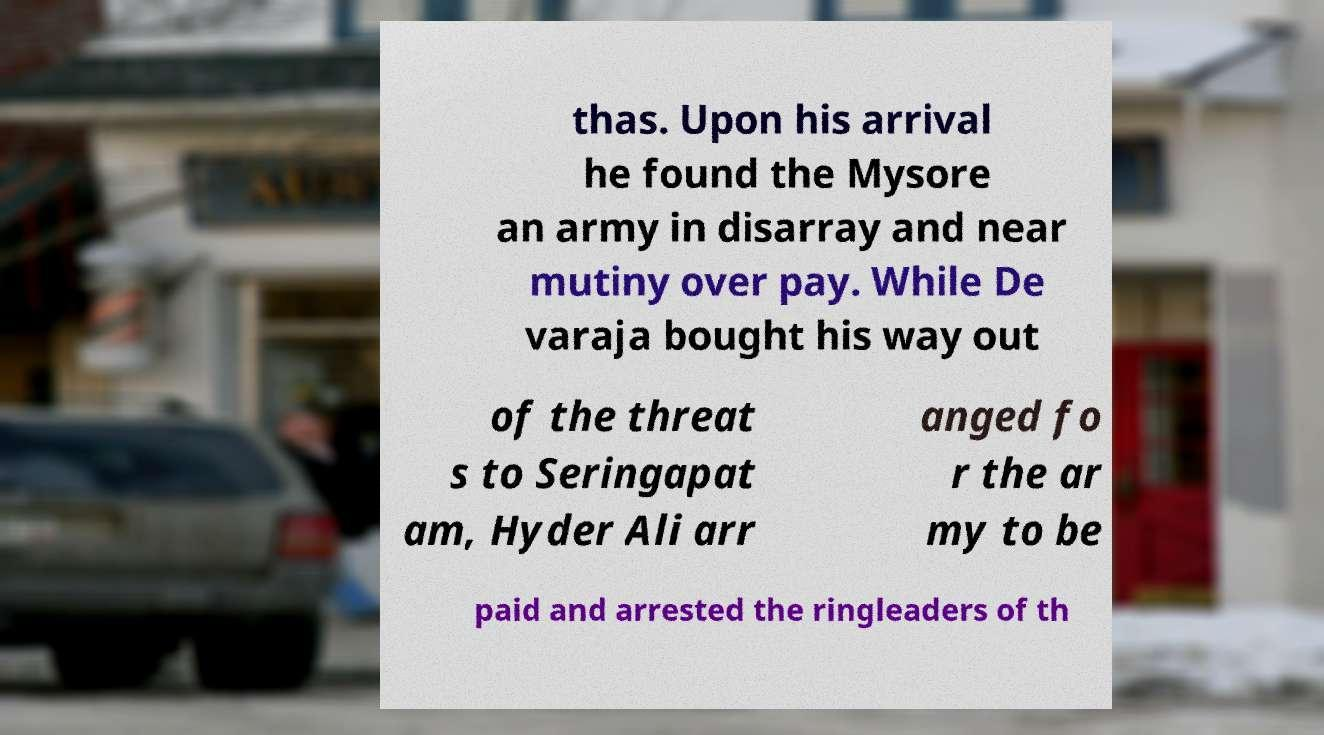Could you extract and type out the text from this image? thas. Upon his arrival he found the Mysore an army in disarray and near mutiny over pay. While De varaja bought his way out of the threat s to Seringapat am, Hyder Ali arr anged fo r the ar my to be paid and arrested the ringleaders of th 